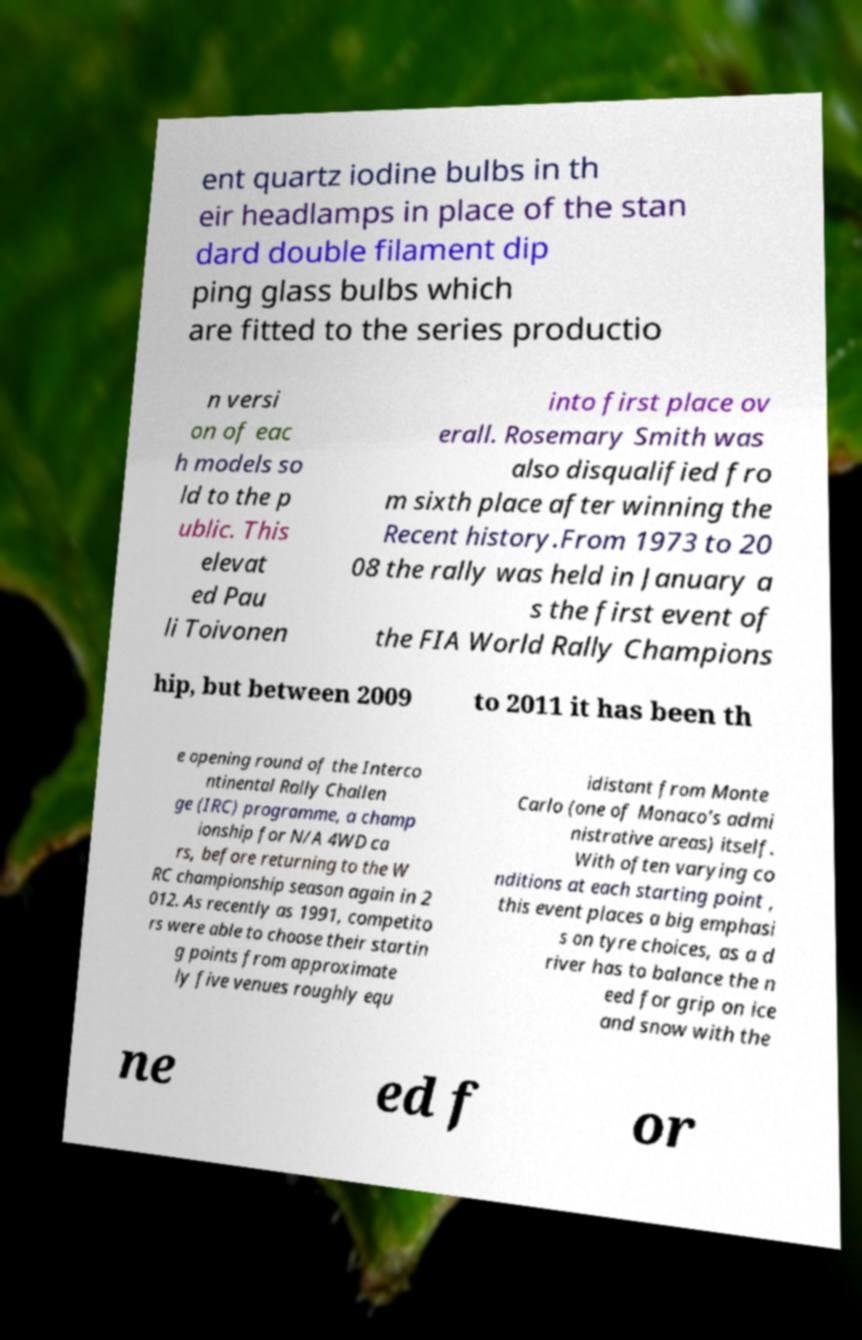Please identify and transcribe the text found in this image. ent quartz iodine bulbs in th eir headlamps in place of the stan dard double filament dip ping glass bulbs which are fitted to the series productio n versi on of eac h models so ld to the p ublic. This elevat ed Pau li Toivonen into first place ov erall. Rosemary Smith was also disqualified fro m sixth place after winning the Recent history.From 1973 to 20 08 the rally was held in January a s the first event of the FIA World Rally Champions hip, but between 2009 to 2011 it has been th e opening round of the Interco ntinental Rally Challen ge (IRC) programme, a champ ionship for N/A 4WD ca rs, before returning to the W RC championship season again in 2 012. As recently as 1991, competito rs were able to choose their startin g points from approximate ly five venues roughly equ idistant from Monte Carlo (one of Monaco's admi nistrative areas) itself. With often varying co nditions at each starting point , this event places a big emphasi s on tyre choices, as a d river has to balance the n eed for grip on ice and snow with the ne ed f or 